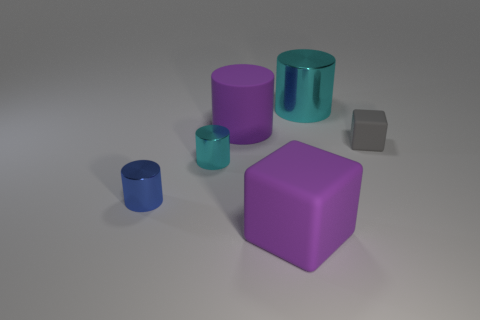How many cyan cylinders must be subtracted to get 1 cyan cylinders? 1 Subtract 1 cylinders. How many cylinders are left? 3 Add 1 cyan cylinders. How many objects exist? 7 Subtract all cubes. How many objects are left? 4 Subtract all tiny green cubes. Subtract all large cubes. How many objects are left? 5 Add 1 tiny cyan objects. How many tiny cyan objects are left? 2 Add 6 purple metal things. How many purple metal things exist? 6 Subtract 0 yellow balls. How many objects are left? 6 